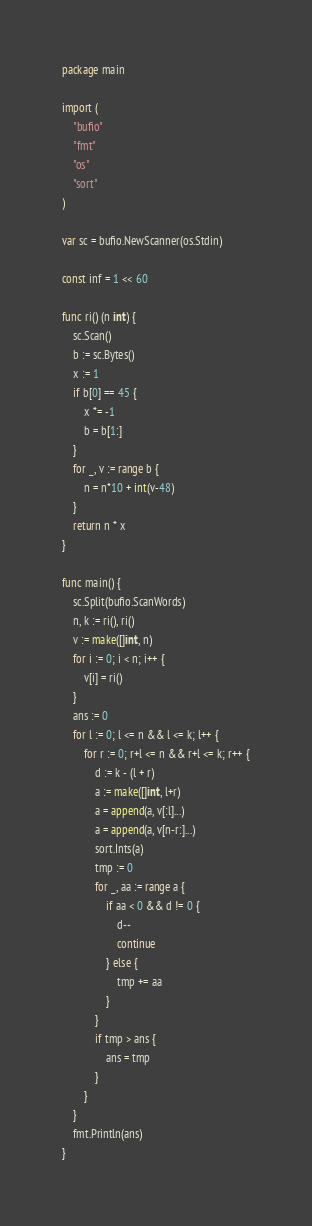<code> <loc_0><loc_0><loc_500><loc_500><_Go_>package main

import (
	"bufio"
	"fmt"
	"os"
	"sort"
)

var sc = bufio.NewScanner(os.Stdin)

const inf = 1 << 60

func ri() (n int) {
	sc.Scan()
	b := sc.Bytes()
	x := 1
	if b[0] == 45 {
		x *= -1
		b = b[1:]
	}
	for _, v := range b {
		n = n*10 + int(v-48)
	}
	return n * x
}

func main() {
	sc.Split(bufio.ScanWords)
	n, k := ri(), ri()
	v := make([]int, n)
	for i := 0; i < n; i++ {
		v[i] = ri()
	}
	ans := 0
	for l := 0; l <= n && l <= k; l++ {
		for r := 0; r+l <= n && r+l <= k; r++ {
			d := k - (l + r)
			a := make([]int, l+r)
			a = append(a, v[:l]...)
			a = append(a, v[n-r:]...)
			sort.Ints(a)
			tmp := 0
			for _, aa := range a {
				if aa < 0 && d != 0 {
					d--
					continue
				} else {
					tmp += aa
				}
			}
			if tmp > ans {
				ans = tmp
			}
		}
	}
	fmt.Println(ans)
}
</code> 